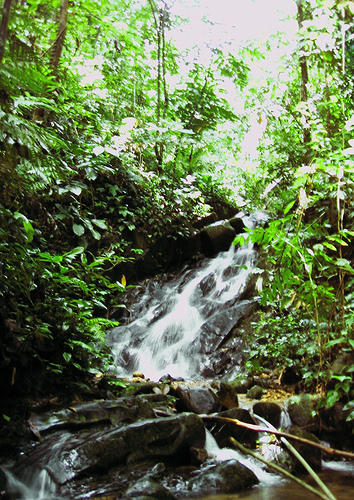<image>
Is the rock behind the tree? No. The rock is not behind the tree. From this viewpoint, the rock appears to be positioned elsewhere in the scene. 